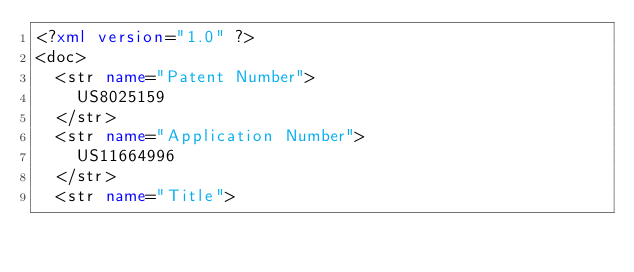<code> <loc_0><loc_0><loc_500><loc_500><_XML_><?xml version="1.0" ?>
<doc>
	<str name="Patent Number">
		US8025159
	</str>
	<str name="Application Number">
		US11664996
	</str>
	<str name="Title"></code> 